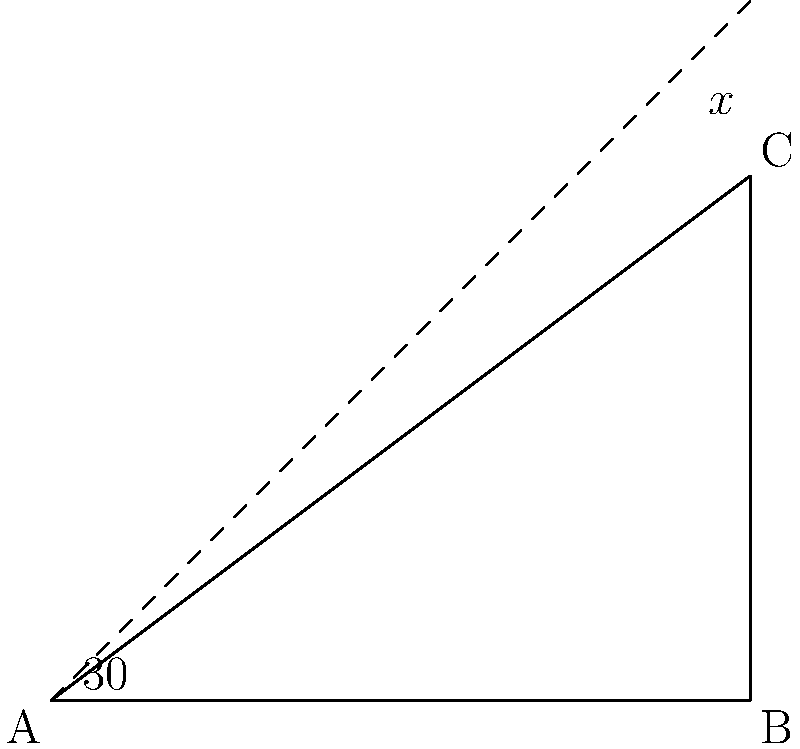In your latest geometric artwork, you've created a triangle ABC with a 30° angle at A. To achieve a balanced composition, you want to add a line from A that forms a right angle with BC. What should be the measure of angle x to create this complementary angle? Let's approach this step-by-step:

1) In a right triangle, the sum of all angles is 90°.

2) We know that one angle is 30°, so the other two angles must sum to 60° (90° - 30° = 60°).

3) In a right triangle, these two angles are complementary, meaning they add up to 90°.

4) To find the complementary angle to the 60° angle we found in step 2, we subtract 60° from 90°:

   90° - 60° = 30°

5) Therefore, the angle x that forms a right angle with BC must be 30°.

This creates a balanced composition by forming two congruent 30-60-90 triangles within the original triangle.
Answer: 30° 